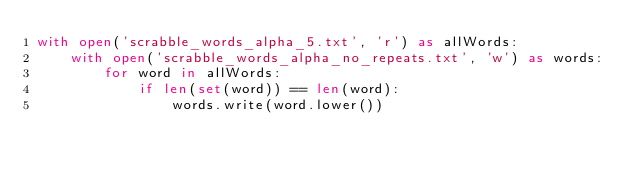<code> <loc_0><loc_0><loc_500><loc_500><_Python_>with open('scrabble_words_alpha_5.txt', 'r') as allWords:
    with open('scrabble_words_alpha_no_repeats.txt', 'w') as words:
        for word in allWords:
            if len(set(word)) == len(word):
                words.write(word.lower())</code> 